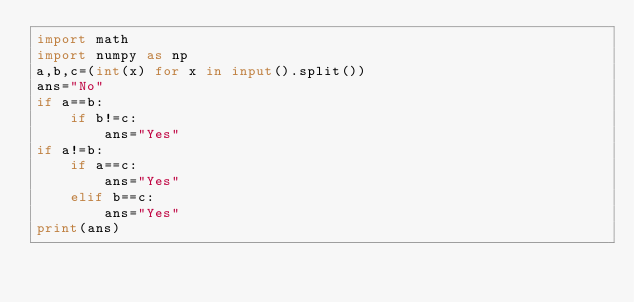<code> <loc_0><loc_0><loc_500><loc_500><_Python_>import math
import numpy as np
a,b,c=(int(x) for x in input().split())
ans="No"
if a==b:
    if b!=c:
        ans="Yes"
if a!=b:
    if a==c:
        ans="Yes"
    elif b==c:
        ans="Yes"
print(ans)

</code> 